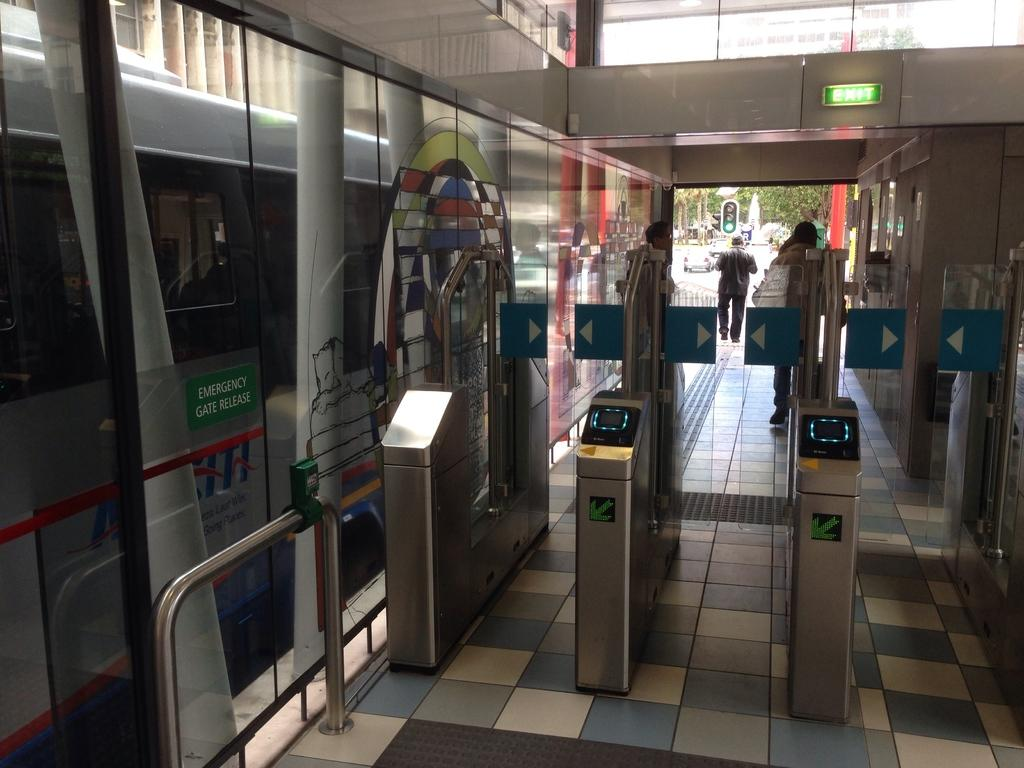<image>
Provide a brief description of the given image. Turnstiles near an exit sign and an emergency gate release sign are near a doorway. 